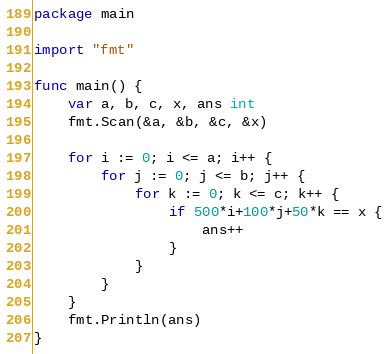<code> <loc_0><loc_0><loc_500><loc_500><_Go_>package main

import "fmt"

func main() {
	var a, b, c, x, ans int
	fmt.Scan(&a, &b, &c, &x)

	for i := 0; i <= a; i++ {
		for j := 0; j <= b; j++ {
			for k := 0; k <= c; k++ {
				if 500*i+100*j+50*k == x {
					ans++
				}
			}
		}
	}
	fmt.Println(ans)
}
</code> 